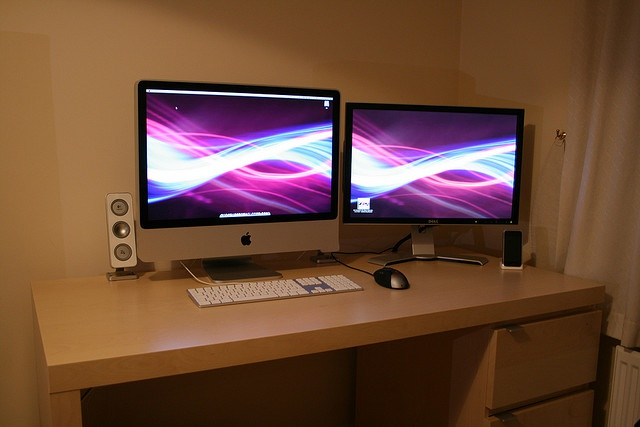Describe the objects in this image and their specific colors. I can see tv in olive, black, maroon, white, and purple tones, tv in olive, black, purple, white, and navy tones, keyboard in olive, tan, gray, and brown tones, cell phone in maroon, black, and olive tones, and mouse in olive, black, maroon, and tan tones in this image. 